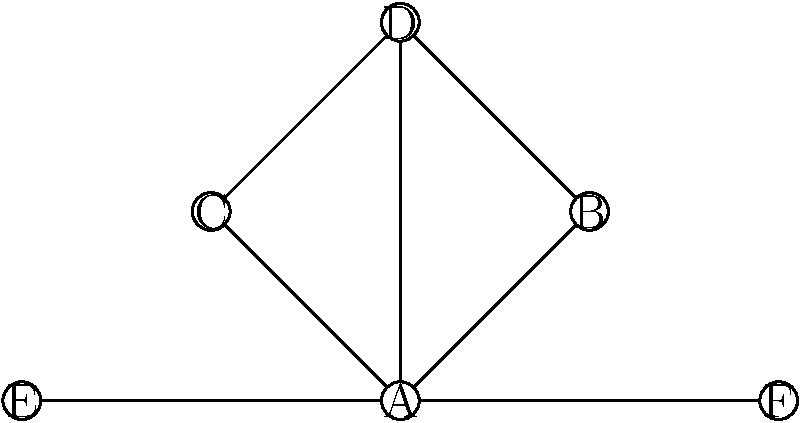In this character relationship network diagram, which character has the highest degree centrality (most direct connections)? How might this impact the realism of the character interactions in a scene? To answer this question, we need to follow these steps:

1. Understand degree centrality: In network analysis, degree centrality is the number of direct connections a node has to other nodes.

2. Count connections for each character:
   A: 5 connections (to B, C, D, E, F)
   B: 2 connections (to A, D)
   C: 2 connections (to A, D)
   D: 3 connections (to A, B, C)
   E: 1 connection (to A)
   F: 1 connection (to A)

3. Identify the character with the highest degree centrality: Character A has 5 connections, which is the highest.

4. Consider the impact on realism:
   - A character with high degree centrality often plays a central role in the story.
   - This character may act as a connector or mediator between other characters.
   - In a realistic scenario, this character might be a protagonist, a leader, or someone in a position that naturally interacts with many others.
   - However, if not handled carefully, having one character with significantly more connections than others could feel contrived or unrealistic.
   - To maintain realism, the high connectivity should be justified by the character's role, personality, or circumstances within the story.
Answer: Character A; potential for unrealistic dominance if not justified by role/context 